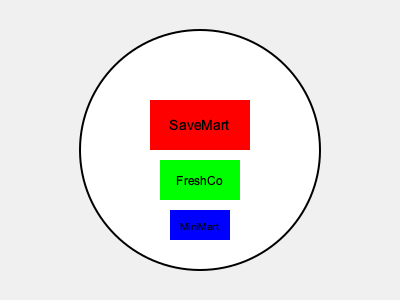While driving through town, you notice three grocery store logos on a circular billboard. The SaveMart logo appears largest, followed by FreshCo, and then MiniMart. If all logos are actually the same size in real life, which store is likely the farthest from your current location? Let's break this down step-by-step:

1. In the image, we see three logos of different sizes on a circular billboard.
2. The question states that all logos are actually the same size in real life.
3. The apparent size of an object decreases as its distance from the viewer increases. This is known as the principle of perspective.
4. The SaveMart logo appears largest, which means it's likely the closest to our current location.
5. The FreshCo logo appears medium-sized, indicating it's farther away than SaveMart but closer than MiniMart.
6. The MiniMart logo appears smallest, suggesting it's the farthest away from our current location.

To visualize this mathematically, we can use the formula for apparent size:

$$ \text{Apparent Size} = \frac{\text{Actual Size}}{\text{Distance}} $$

Since the actual sizes are the same, the apparent size is inversely proportional to the distance. The smallest apparent size (MiniMart) corresponds to the largest distance.
Answer: MiniMart 